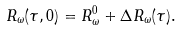<formula> <loc_0><loc_0><loc_500><loc_500>R _ { \omega } ( \tau , 0 ) = R _ { \omega } ^ { 0 } + \Delta R _ { \omega } ( \tau ) .</formula> 